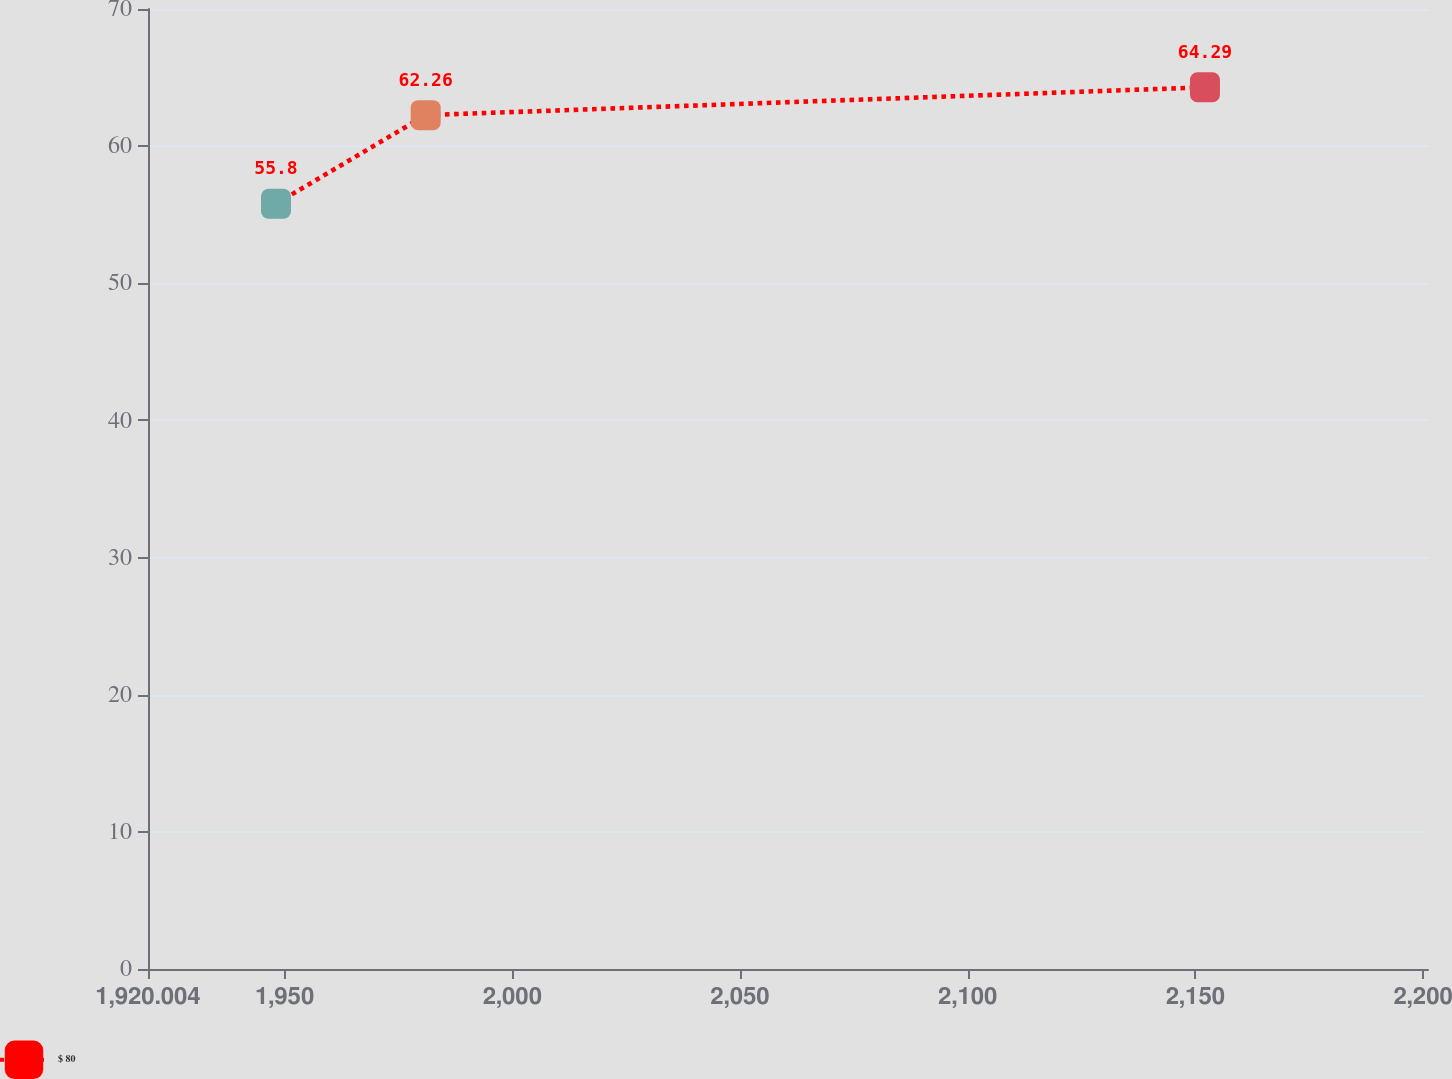Convert chart to OTSL. <chart><loc_0><loc_0><loc_500><loc_500><line_chart><ecel><fcel>$ 80<nl><fcel>1948.11<fcel>55.8<nl><fcel>1980.98<fcel>62.26<nl><fcel>2152.09<fcel>64.29<nl><fcel>2229.17<fcel>54.86<nl></chart> 